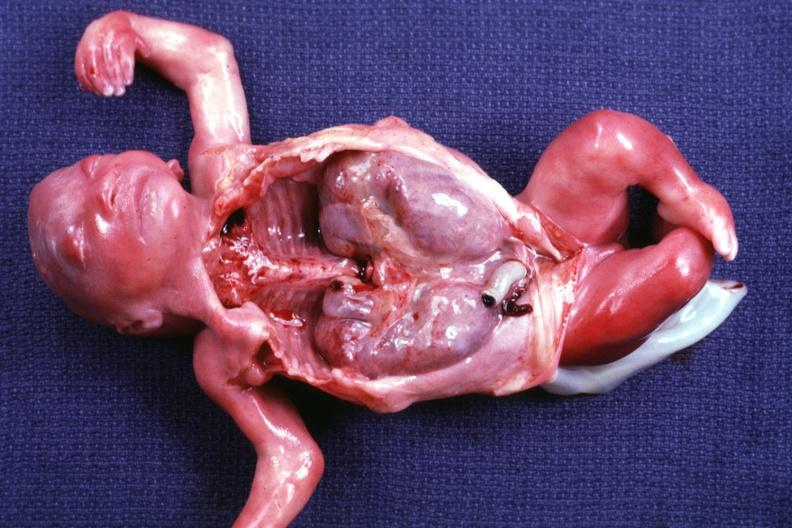s opened dysmorphic body with all organs except kidneys removed shows size of organs quite well and renal facies?
Answer the question using a single word or phrase. Yes 